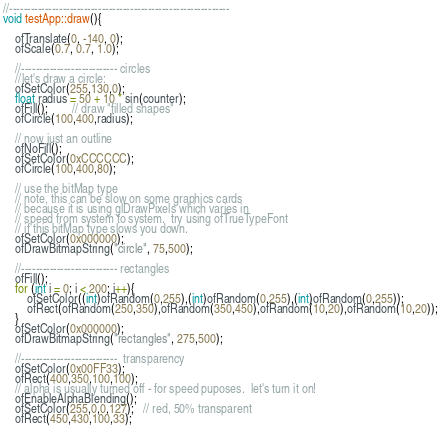<code> <loc_0><loc_0><loc_500><loc_500><_ObjectiveC_>
//--------------------------------------------------------------
void testApp::draw(){

	ofTranslate(0, -140, 0);
	ofScale(0.7, 0.7, 1.0);
	
	//--------------------------- circles
	//let's draw a circle:
	ofSetColor(255,130,0);
	float radius = 50 + 10 * sin(counter);
	ofFill();		// draw "filled shapes"
	ofCircle(100,400,radius);

	// now just an outline
	ofNoFill();
	ofSetColor(0xCCCCCC);
	ofCircle(100,400,80);

	// use the bitMap type
	// note, this can be slow on some graphics cards
	// because it is using glDrawPixels which varies in
	// speed from system to system.  try using ofTrueTypeFont
	// if this bitMap type slows you down.
	ofSetColor(0x000000);
	ofDrawBitmapString("circle", 75,500);

	//--------------------------- rectangles
	ofFill();
	for (int i = 0; i < 200; i++){
		ofSetColor((int)ofRandom(0,255),(int)ofRandom(0,255),(int)ofRandom(0,255));
		ofRect(ofRandom(250,350),ofRandom(350,450),ofRandom(10,20),ofRandom(10,20));
	}
	ofSetColor(0x000000);
	ofDrawBitmapString("rectangles", 275,500);

	//---------------------------  transparency
	ofSetColor(0x00FF33);
	ofRect(400,350,100,100);
	// alpha is usually turned off - for speed puposes.  let's turn it on!
	ofEnableAlphaBlending();
	ofSetColor(255,0,0,127);   // red, 50% transparent
	ofRect(450,430,100,33);</code> 